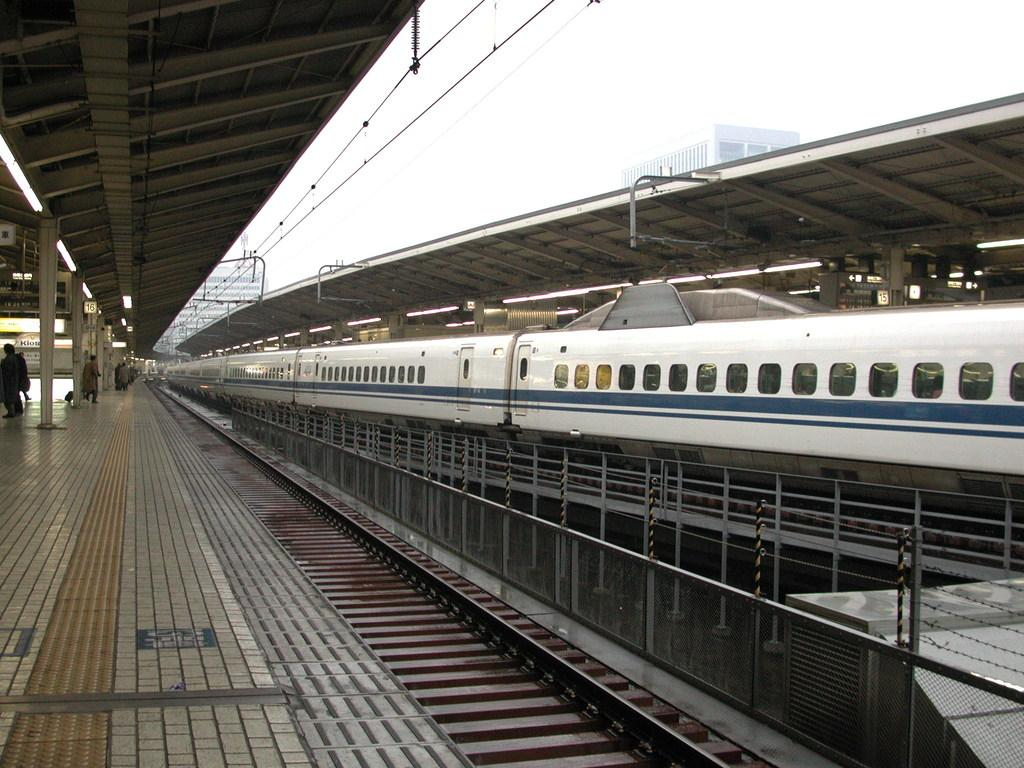What is the main subject of the image? The main subject of the image is a train. Where is the train located? The train is on a railway track. What is the color of the train? The train is white and blue in color. What feature allows passengers to see outside the train? There are windows on the train. Can you see any people inside the train? Yes, there are people visible inside the train. What structures are present in the image besides the train? There are pillars, a shed, fencing, and wires in the image. What is the color of the sky in the image? The sky is white in color. Where is the store located in the image? There is no store present in the image. What type of chain is used to secure the train in the image? There is no chain visible in the image. What reward can be seen being given to the passengers in the image? There is no reward being given to passengers in the image. 